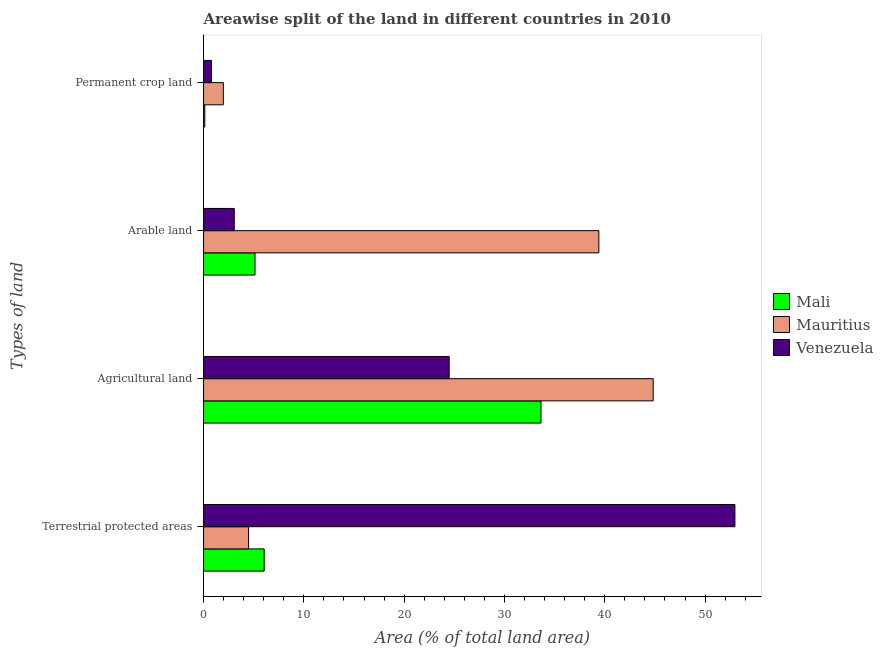How many different coloured bars are there?
Offer a very short reply. 3. How many groups of bars are there?
Offer a very short reply. 4. How many bars are there on the 1st tick from the top?
Give a very brief answer. 3. What is the label of the 4th group of bars from the top?
Provide a short and direct response. Terrestrial protected areas. What is the percentage of area under permanent crop land in Mauritius?
Your answer should be compact. 1.97. Across all countries, what is the maximum percentage of area under permanent crop land?
Offer a terse response. 1.97. Across all countries, what is the minimum percentage of land under terrestrial protection?
Offer a very short reply. 4.49. In which country was the percentage of area under agricultural land maximum?
Make the answer very short. Mauritius. In which country was the percentage of area under permanent crop land minimum?
Keep it short and to the point. Mali. What is the total percentage of land under terrestrial protection in the graph?
Keep it short and to the point. 63.5. What is the difference between the percentage of area under agricultural land in Mali and that in Mauritius?
Offer a terse response. -11.18. What is the difference between the percentage of area under arable land in Mali and the percentage of land under terrestrial protection in Mauritius?
Give a very brief answer. 0.65. What is the average percentage of area under permanent crop land per country?
Your answer should be very brief. 0.96. What is the difference between the percentage of area under agricultural land and percentage of area under permanent crop land in Mali?
Keep it short and to the point. 33.52. What is the ratio of the percentage of area under permanent crop land in Mauritius to that in Venezuela?
Your answer should be compact. 2.48. Is the percentage of area under agricultural land in Venezuela less than that in Mali?
Offer a terse response. Yes. Is the difference between the percentage of area under arable land in Venezuela and Mauritius greater than the difference between the percentage of area under permanent crop land in Venezuela and Mauritius?
Offer a very short reply. No. What is the difference between the highest and the second highest percentage of land under terrestrial protection?
Give a very brief answer. 46.93. What is the difference between the highest and the lowest percentage of area under agricultural land?
Ensure brevity in your answer.  20.34. In how many countries, is the percentage of land under terrestrial protection greater than the average percentage of land under terrestrial protection taken over all countries?
Offer a terse response. 1. Is it the case that in every country, the sum of the percentage of area under arable land and percentage of area under agricultural land is greater than the sum of percentage of land under terrestrial protection and percentage of area under permanent crop land?
Offer a terse response. Yes. What does the 3rd bar from the top in Arable land represents?
Provide a succinct answer. Mali. What does the 1st bar from the bottom in Agricultural land represents?
Ensure brevity in your answer.  Mali. Is it the case that in every country, the sum of the percentage of land under terrestrial protection and percentage of area under agricultural land is greater than the percentage of area under arable land?
Your answer should be compact. Yes. Are all the bars in the graph horizontal?
Give a very brief answer. Yes. What is the difference between two consecutive major ticks on the X-axis?
Offer a very short reply. 10. Are the values on the major ticks of X-axis written in scientific E-notation?
Provide a succinct answer. No. Where does the legend appear in the graph?
Offer a very short reply. Center right. How many legend labels are there?
Make the answer very short. 3. What is the title of the graph?
Keep it short and to the point. Areawise split of the land in different countries in 2010. Does "Ecuador" appear as one of the legend labels in the graph?
Give a very brief answer. No. What is the label or title of the X-axis?
Provide a short and direct response. Area (% of total land area). What is the label or title of the Y-axis?
Ensure brevity in your answer.  Types of land. What is the Area (% of total land area) in Mali in Terrestrial protected areas?
Make the answer very short. 6.05. What is the Area (% of total land area) of Mauritius in Terrestrial protected areas?
Your answer should be very brief. 4.49. What is the Area (% of total land area) of Venezuela in Terrestrial protected areas?
Your answer should be very brief. 52.97. What is the Area (% of total land area) in Mali in Agricultural land?
Provide a short and direct response. 33.64. What is the Area (% of total land area) in Mauritius in Agricultural land?
Your response must be concise. 44.83. What is the Area (% of total land area) of Venezuela in Agricultural land?
Keep it short and to the point. 24.49. What is the Area (% of total land area) in Mali in Arable land?
Make the answer very short. 5.13. What is the Area (% of total land area) in Mauritius in Arable land?
Your answer should be very brief. 39.41. What is the Area (% of total land area) in Venezuela in Arable land?
Your answer should be very brief. 3.06. What is the Area (% of total land area) in Mali in Permanent crop land?
Provide a short and direct response. 0.12. What is the Area (% of total land area) in Mauritius in Permanent crop land?
Give a very brief answer. 1.97. What is the Area (% of total land area) in Venezuela in Permanent crop land?
Keep it short and to the point. 0.79. Across all Types of land, what is the maximum Area (% of total land area) of Mali?
Ensure brevity in your answer.  33.64. Across all Types of land, what is the maximum Area (% of total land area) in Mauritius?
Provide a short and direct response. 44.83. Across all Types of land, what is the maximum Area (% of total land area) of Venezuela?
Ensure brevity in your answer.  52.97. Across all Types of land, what is the minimum Area (% of total land area) of Mali?
Make the answer very short. 0.12. Across all Types of land, what is the minimum Area (% of total land area) of Mauritius?
Offer a very short reply. 1.97. Across all Types of land, what is the minimum Area (% of total land area) in Venezuela?
Give a very brief answer. 0.79. What is the total Area (% of total land area) of Mali in the graph?
Your response must be concise. 44.94. What is the total Area (% of total land area) in Mauritius in the graph?
Offer a very short reply. 90.69. What is the total Area (% of total land area) in Venezuela in the graph?
Give a very brief answer. 81.32. What is the difference between the Area (% of total land area) of Mali in Terrestrial protected areas and that in Agricultural land?
Ensure brevity in your answer.  -27.6. What is the difference between the Area (% of total land area) in Mauritius in Terrestrial protected areas and that in Agricultural land?
Ensure brevity in your answer.  -40.34. What is the difference between the Area (% of total land area) of Venezuela in Terrestrial protected areas and that in Agricultural land?
Your response must be concise. 28.48. What is the difference between the Area (% of total land area) of Mali in Terrestrial protected areas and that in Arable land?
Your response must be concise. 0.91. What is the difference between the Area (% of total land area) in Mauritius in Terrestrial protected areas and that in Arable land?
Ensure brevity in your answer.  -34.92. What is the difference between the Area (% of total land area) of Venezuela in Terrestrial protected areas and that in Arable land?
Make the answer very short. 49.91. What is the difference between the Area (% of total land area) of Mali in Terrestrial protected areas and that in Permanent crop land?
Your response must be concise. 5.92. What is the difference between the Area (% of total land area) of Mauritius in Terrestrial protected areas and that in Permanent crop land?
Your response must be concise. 2.52. What is the difference between the Area (% of total land area) in Venezuela in Terrestrial protected areas and that in Permanent crop land?
Keep it short and to the point. 52.18. What is the difference between the Area (% of total land area) in Mali in Agricultural land and that in Arable land?
Give a very brief answer. 28.51. What is the difference between the Area (% of total land area) in Mauritius in Agricultural land and that in Arable land?
Your answer should be very brief. 5.42. What is the difference between the Area (% of total land area) in Venezuela in Agricultural land and that in Arable land?
Offer a terse response. 21.43. What is the difference between the Area (% of total land area) of Mali in Agricultural land and that in Permanent crop land?
Provide a succinct answer. 33.52. What is the difference between the Area (% of total land area) of Mauritius in Agricultural land and that in Permanent crop land?
Your answer should be very brief. 42.86. What is the difference between the Area (% of total land area) in Venezuela in Agricultural land and that in Permanent crop land?
Provide a short and direct response. 23.69. What is the difference between the Area (% of total land area) in Mali in Arable land and that in Permanent crop land?
Keep it short and to the point. 5.01. What is the difference between the Area (% of total land area) in Mauritius in Arable land and that in Permanent crop land?
Ensure brevity in your answer.  37.44. What is the difference between the Area (% of total land area) in Venezuela in Arable land and that in Permanent crop land?
Keep it short and to the point. 2.27. What is the difference between the Area (% of total land area) of Mali in Terrestrial protected areas and the Area (% of total land area) of Mauritius in Agricultural land?
Provide a succinct answer. -38.78. What is the difference between the Area (% of total land area) of Mali in Terrestrial protected areas and the Area (% of total land area) of Venezuela in Agricultural land?
Provide a succinct answer. -18.44. What is the difference between the Area (% of total land area) in Mauritius in Terrestrial protected areas and the Area (% of total land area) in Venezuela in Agricultural land?
Provide a short and direct response. -20. What is the difference between the Area (% of total land area) of Mali in Terrestrial protected areas and the Area (% of total land area) of Mauritius in Arable land?
Offer a very short reply. -33.36. What is the difference between the Area (% of total land area) of Mali in Terrestrial protected areas and the Area (% of total land area) of Venezuela in Arable land?
Keep it short and to the point. 2.98. What is the difference between the Area (% of total land area) in Mauritius in Terrestrial protected areas and the Area (% of total land area) in Venezuela in Arable land?
Make the answer very short. 1.42. What is the difference between the Area (% of total land area) in Mali in Terrestrial protected areas and the Area (% of total land area) in Mauritius in Permanent crop land?
Your answer should be compact. 4.07. What is the difference between the Area (% of total land area) in Mali in Terrestrial protected areas and the Area (% of total land area) in Venezuela in Permanent crop land?
Offer a very short reply. 5.25. What is the difference between the Area (% of total land area) of Mauritius in Terrestrial protected areas and the Area (% of total land area) of Venezuela in Permanent crop land?
Make the answer very short. 3.69. What is the difference between the Area (% of total land area) in Mali in Agricultural land and the Area (% of total land area) in Mauritius in Arable land?
Offer a very short reply. -5.77. What is the difference between the Area (% of total land area) of Mali in Agricultural land and the Area (% of total land area) of Venezuela in Arable land?
Offer a terse response. 30.58. What is the difference between the Area (% of total land area) of Mauritius in Agricultural land and the Area (% of total land area) of Venezuela in Arable land?
Keep it short and to the point. 41.77. What is the difference between the Area (% of total land area) in Mali in Agricultural land and the Area (% of total land area) in Mauritius in Permanent crop land?
Provide a succinct answer. 31.67. What is the difference between the Area (% of total land area) in Mali in Agricultural land and the Area (% of total land area) in Venezuela in Permanent crop land?
Your answer should be compact. 32.85. What is the difference between the Area (% of total land area) of Mauritius in Agricultural land and the Area (% of total land area) of Venezuela in Permanent crop land?
Ensure brevity in your answer.  44.03. What is the difference between the Area (% of total land area) in Mali in Arable land and the Area (% of total land area) in Mauritius in Permanent crop land?
Your response must be concise. 3.16. What is the difference between the Area (% of total land area) of Mali in Arable land and the Area (% of total land area) of Venezuela in Permanent crop land?
Keep it short and to the point. 4.34. What is the difference between the Area (% of total land area) of Mauritius in Arable land and the Area (% of total land area) of Venezuela in Permanent crop land?
Provide a succinct answer. 38.62. What is the average Area (% of total land area) in Mali per Types of land?
Your answer should be very brief. 11.24. What is the average Area (% of total land area) in Mauritius per Types of land?
Your response must be concise. 22.67. What is the average Area (% of total land area) of Venezuela per Types of land?
Provide a short and direct response. 20.33. What is the difference between the Area (% of total land area) in Mali and Area (% of total land area) in Mauritius in Terrestrial protected areas?
Keep it short and to the point. 1.56. What is the difference between the Area (% of total land area) of Mali and Area (% of total land area) of Venezuela in Terrestrial protected areas?
Make the answer very short. -46.93. What is the difference between the Area (% of total land area) in Mauritius and Area (% of total land area) in Venezuela in Terrestrial protected areas?
Provide a short and direct response. -48.49. What is the difference between the Area (% of total land area) in Mali and Area (% of total land area) in Mauritius in Agricultural land?
Offer a terse response. -11.18. What is the difference between the Area (% of total land area) of Mali and Area (% of total land area) of Venezuela in Agricultural land?
Give a very brief answer. 9.15. What is the difference between the Area (% of total land area) in Mauritius and Area (% of total land area) in Venezuela in Agricultural land?
Provide a short and direct response. 20.34. What is the difference between the Area (% of total land area) of Mali and Area (% of total land area) of Mauritius in Arable land?
Ensure brevity in your answer.  -34.28. What is the difference between the Area (% of total land area) of Mali and Area (% of total land area) of Venezuela in Arable land?
Your answer should be very brief. 2.07. What is the difference between the Area (% of total land area) of Mauritius and Area (% of total land area) of Venezuela in Arable land?
Offer a terse response. 36.35. What is the difference between the Area (% of total land area) of Mali and Area (% of total land area) of Mauritius in Permanent crop land?
Keep it short and to the point. -1.85. What is the difference between the Area (% of total land area) in Mali and Area (% of total land area) in Venezuela in Permanent crop land?
Provide a succinct answer. -0.67. What is the difference between the Area (% of total land area) of Mauritius and Area (% of total land area) of Venezuela in Permanent crop land?
Your answer should be very brief. 1.18. What is the ratio of the Area (% of total land area) of Mali in Terrestrial protected areas to that in Agricultural land?
Provide a succinct answer. 0.18. What is the ratio of the Area (% of total land area) of Mauritius in Terrestrial protected areas to that in Agricultural land?
Your answer should be very brief. 0.1. What is the ratio of the Area (% of total land area) in Venezuela in Terrestrial protected areas to that in Agricultural land?
Offer a terse response. 2.16. What is the ratio of the Area (% of total land area) in Mali in Terrestrial protected areas to that in Arable land?
Offer a terse response. 1.18. What is the ratio of the Area (% of total land area) of Mauritius in Terrestrial protected areas to that in Arable land?
Offer a very short reply. 0.11. What is the ratio of the Area (% of total land area) in Venezuela in Terrestrial protected areas to that in Arable land?
Make the answer very short. 17.31. What is the ratio of the Area (% of total land area) in Mali in Terrestrial protected areas to that in Permanent crop land?
Your answer should be very brief. 49.18. What is the ratio of the Area (% of total land area) in Mauritius in Terrestrial protected areas to that in Permanent crop land?
Make the answer very short. 2.28. What is the ratio of the Area (% of total land area) of Venezuela in Terrestrial protected areas to that in Permanent crop land?
Provide a short and direct response. 66.75. What is the ratio of the Area (% of total land area) of Mali in Agricultural land to that in Arable land?
Your answer should be very brief. 6.56. What is the ratio of the Area (% of total land area) of Mauritius in Agricultural land to that in Arable land?
Your answer should be very brief. 1.14. What is the ratio of the Area (% of total land area) in Venezuela in Agricultural land to that in Arable land?
Your answer should be very brief. 8. What is the ratio of the Area (% of total land area) in Mali in Agricultural land to that in Permanent crop land?
Keep it short and to the point. 273.67. What is the ratio of the Area (% of total land area) of Mauritius in Agricultural land to that in Permanent crop land?
Ensure brevity in your answer.  22.75. What is the ratio of the Area (% of total land area) in Venezuela in Agricultural land to that in Permanent crop land?
Ensure brevity in your answer.  30.86. What is the ratio of the Area (% of total land area) of Mali in Arable land to that in Permanent crop land?
Ensure brevity in your answer.  41.74. What is the ratio of the Area (% of total land area) of Venezuela in Arable land to that in Permanent crop land?
Keep it short and to the point. 3.86. What is the difference between the highest and the second highest Area (% of total land area) in Mali?
Keep it short and to the point. 27.6. What is the difference between the highest and the second highest Area (% of total land area) in Mauritius?
Offer a very short reply. 5.42. What is the difference between the highest and the second highest Area (% of total land area) in Venezuela?
Ensure brevity in your answer.  28.48. What is the difference between the highest and the lowest Area (% of total land area) of Mali?
Provide a short and direct response. 33.52. What is the difference between the highest and the lowest Area (% of total land area) of Mauritius?
Offer a terse response. 42.86. What is the difference between the highest and the lowest Area (% of total land area) in Venezuela?
Give a very brief answer. 52.18. 